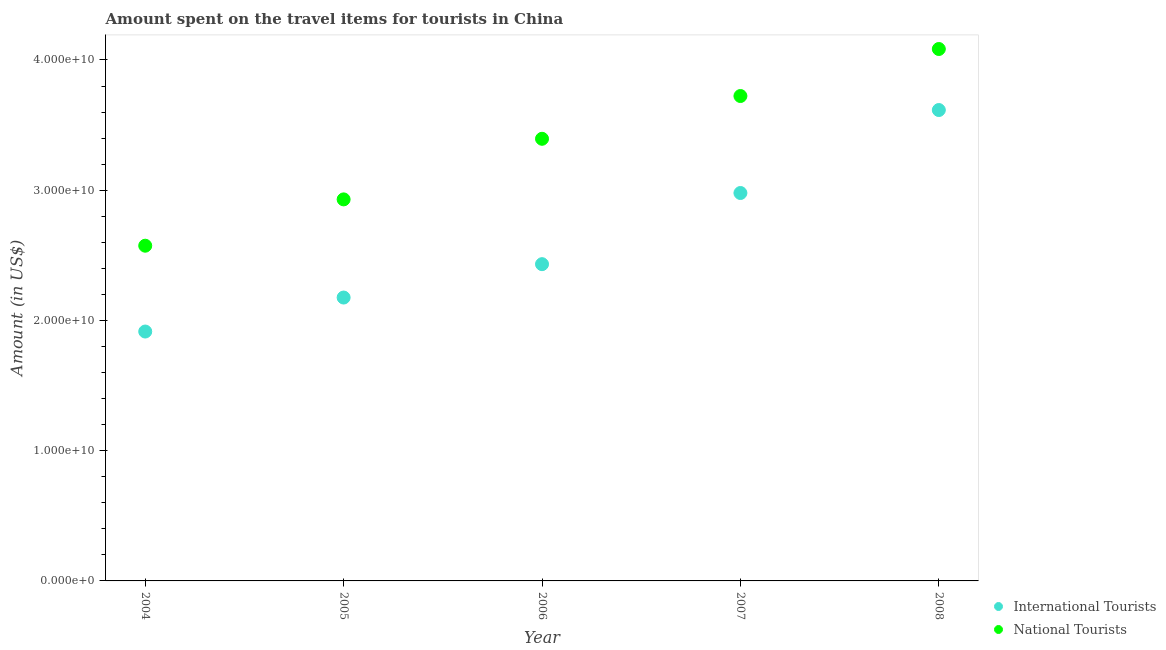Is the number of dotlines equal to the number of legend labels?
Your answer should be very brief. Yes. What is the amount spent on travel items of national tourists in 2006?
Your answer should be very brief. 3.39e+1. Across all years, what is the maximum amount spent on travel items of international tourists?
Make the answer very short. 3.62e+1. Across all years, what is the minimum amount spent on travel items of international tourists?
Offer a terse response. 1.91e+1. In which year was the amount spent on travel items of international tourists minimum?
Keep it short and to the point. 2004. What is the total amount spent on travel items of national tourists in the graph?
Your answer should be very brief. 1.67e+11. What is the difference between the amount spent on travel items of national tourists in 2006 and that in 2007?
Provide a succinct answer. -3.28e+09. What is the difference between the amount spent on travel items of international tourists in 2007 and the amount spent on travel items of national tourists in 2005?
Offer a terse response. 4.90e+08. What is the average amount spent on travel items of national tourists per year?
Provide a succinct answer. 3.34e+1. In the year 2006, what is the difference between the amount spent on travel items of international tourists and amount spent on travel items of national tourists?
Make the answer very short. -9.63e+09. In how many years, is the amount spent on travel items of national tourists greater than 22000000000 US$?
Give a very brief answer. 5. What is the ratio of the amount spent on travel items of national tourists in 2005 to that in 2008?
Ensure brevity in your answer.  0.72. What is the difference between the highest and the second highest amount spent on travel items of international tourists?
Give a very brief answer. 6.37e+09. What is the difference between the highest and the lowest amount spent on travel items of international tourists?
Provide a succinct answer. 1.70e+1. In how many years, is the amount spent on travel items of national tourists greater than the average amount spent on travel items of national tourists taken over all years?
Provide a succinct answer. 3. Does the amount spent on travel items of national tourists monotonically increase over the years?
Your answer should be very brief. Yes. How many dotlines are there?
Offer a very short reply. 2. How many years are there in the graph?
Offer a terse response. 5. What is the difference between two consecutive major ticks on the Y-axis?
Provide a succinct answer. 1.00e+1. Are the values on the major ticks of Y-axis written in scientific E-notation?
Offer a very short reply. Yes. Does the graph contain any zero values?
Offer a terse response. No. Does the graph contain grids?
Your answer should be very brief. No. How are the legend labels stacked?
Offer a terse response. Vertical. What is the title of the graph?
Offer a terse response. Amount spent on the travel items for tourists in China. Does "Highest 20% of population" appear as one of the legend labels in the graph?
Offer a terse response. No. What is the label or title of the Y-axis?
Your response must be concise. Amount (in US$). What is the Amount (in US$) of International Tourists in 2004?
Offer a very short reply. 1.91e+1. What is the Amount (in US$) in National Tourists in 2004?
Ensure brevity in your answer.  2.57e+1. What is the Amount (in US$) in International Tourists in 2005?
Keep it short and to the point. 2.18e+1. What is the Amount (in US$) in National Tourists in 2005?
Keep it short and to the point. 2.93e+1. What is the Amount (in US$) in International Tourists in 2006?
Ensure brevity in your answer.  2.43e+1. What is the Amount (in US$) in National Tourists in 2006?
Your answer should be compact. 3.39e+1. What is the Amount (in US$) in International Tourists in 2007?
Your answer should be very brief. 2.98e+1. What is the Amount (in US$) of National Tourists in 2007?
Provide a short and direct response. 3.72e+1. What is the Amount (in US$) in International Tourists in 2008?
Your answer should be compact. 3.62e+1. What is the Amount (in US$) of National Tourists in 2008?
Offer a very short reply. 4.08e+1. Across all years, what is the maximum Amount (in US$) in International Tourists?
Keep it short and to the point. 3.62e+1. Across all years, what is the maximum Amount (in US$) of National Tourists?
Offer a terse response. 4.08e+1. Across all years, what is the minimum Amount (in US$) in International Tourists?
Give a very brief answer. 1.91e+1. Across all years, what is the minimum Amount (in US$) of National Tourists?
Provide a succinct answer. 2.57e+1. What is the total Amount (in US$) in International Tourists in the graph?
Provide a short and direct response. 1.31e+11. What is the total Amount (in US$) in National Tourists in the graph?
Your response must be concise. 1.67e+11. What is the difference between the Amount (in US$) of International Tourists in 2004 and that in 2005?
Provide a succinct answer. -2.61e+09. What is the difference between the Amount (in US$) of National Tourists in 2004 and that in 2005?
Provide a short and direct response. -3.56e+09. What is the difference between the Amount (in US$) of International Tourists in 2004 and that in 2006?
Your answer should be very brief. -5.17e+09. What is the difference between the Amount (in US$) in National Tourists in 2004 and that in 2006?
Your answer should be very brief. -8.21e+09. What is the difference between the Amount (in US$) in International Tourists in 2004 and that in 2007?
Offer a terse response. -1.06e+1. What is the difference between the Amount (in US$) of National Tourists in 2004 and that in 2007?
Give a very brief answer. -1.15e+1. What is the difference between the Amount (in US$) in International Tourists in 2004 and that in 2008?
Provide a succinct answer. -1.70e+1. What is the difference between the Amount (in US$) in National Tourists in 2004 and that in 2008?
Offer a very short reply. -1.51e+1. What is the difference between the Amount (in US$) in International Tourists in 2005 and that in 2006?
Offer a terse response. -2.56e+09. What is the difference between the Amount (in US$) of National Tourists in 2005 and that in 2006?
Offer a very short reply. -4.65e+09. What is the difference between the Amount (in US$) in International Tourists in 2005 and that in 2007?
Keep it short and to the point. -8.03e+09. What is the difference between the Amount (in US$) of National Tourists in 2005 and that in 2007?
Offer a terse response. -7.94e+09. What is the difference between the Amount (in US$) in International Tourists in 2005 and that in 2008?
Keep it short and to the point. -1.44e+1. What is the difference between the Amount (in US$) in National Tourists in 2005 and that in 2008?
Your response must be concise. -1.15e+1. What is the difference between the Amount (in US$) in International Tourists in 2006 and that in 2007?
Keep it short and to the point. -5.46e+09. What is the difference between the Amount (in US$) of National Tourists in 2006 and that in 2007?
Offer a very short reply. -3.28e+09. What is the difference between the Amount (in US$) of International Tourists in 2006 and that in 2008?
Make the answer very short. -1.18e+1. What is the difference between the Amount (in US$) in National Tourists in 2006 and that in 2008?
Provide a short and direct response. -6.89e+09. What is the difference between the Amount (in US$) of International Tourists in 2007 and that in 2008?
Offer a very short reply. -6.37e+09. What is the difference between the Amount (in US$) of National Tourists in 2007 and that in 2008?
Keep it short and to the point. -3.61e+09. What is the difference between the Amount (in US$) in International Tourists in 2004 and the Amount (in US$) in National Tourists in 2005?
Offer a terse response. -1.01e+1. What is the difference between the Amount (in US$) of International Tourists in 2004 and the Amount (in US$) of National Tourists in 2006?
Your response must be concise. -1.48e+1. What is the difference between the Amount (in US$) in International Tourists in 2004 and the Amount (in US$) in National Tourists in 2007?
Your answer should be very brief. -1.81e+1. What is the difference between the Amount (in US$) in International Tourists in 2004 and the Amount (in US$) in National Tourists in 2008?
Your response must be concise. -2.17e+1. What is the difference between the Amount (in US$) in International Tourists in 2005 and the Amount (in US$) in National Tourists in 2006?
Offer a terse response. -1.22e+1. What is the difference between the Amount (in US$) in International Tourists in 2005 and the Amount (in US$) in National Tourists in 2007?
Provide a short and direct response. -1.55e+1. What is the difference between the Amount (in US$) of International Tourists in 2005 and the Amount (in US$) of National Tourists in 2008?
Offer a very short reply. -1.91e+1. What is the difference between the Amount (in US$) in International Tourists in 2006 and the Amount (in US$) in National Tourists in 2007?
Make the answer very short. -1.29e+1. What is the difference between the Amount (in US$) in International Tourists in 2006 and the Amount (in US$) in National Tourists in 2008?
Your answer should be very brief. -1.65e+1. What is the difference between the Amount (in US$) of International Tourists in 2007 and the Amount (in US$) of National Tourists in 2008?
Offer a terse response. -1.11e+1. What is the average Amount (in US$) of International Tourists per year?
Give a very brief answer. 2.62e+1. What is the average Amount (in US$) in National Tourists per year?
Provide a short and direct response. 3.34e+1. In the year 2004, what is the difference between the Amount (in US$) of International Tourists and Amount (in US$) of National Tourists?
Provide a short and direct response. -6.59e+09. In the year 2005, what is the difference between the Amount (in US$) in International Tourists and Amount (in US$) in National Tourists?
Give a very brief answer. -7.54e+09. In the year 2006, what is the difference between the Amount (in US$) of International Tourists and Amount (in US$) of National Tourists?
Offer a very short reply. -9.63e+09. In the year 2007, what is the difference between the Amount (in US$) of International Tourists and Amount (in US$) of National Tourists?
Keep it short and to the point. -7.45e+09. In the year 2008, what is the difference between the Amount (in US$) in International Tourists and Amount (in US$) in National Tourists?
Provide a succinct answer. -4.69e+09. What is the ratio of the Amount (in US$) in National Tourists in 2004 to that in 2005?
Offer a terse response. 0.88. What is the ratio of the Amount (in US$) in International Tourists in 2004 to that in 2006?
Your answer should be very brief. 0.79. What is the ratio of the Amount (in US$) in National Tourists in 2004 to that in 2006?
Offer a terse response. 0.76. What is the ratio of the Amount (in US$) in International Tourists in 2004 to that in 2007?
Keep it short and to the point. 0.64. What is the ratio of the Amount (in US$) in National Tourists in 2004 to that in 2007?
Provide a succinct answer. 0.69. What is the ratio of the Amount (in US$) in International Tourists in 2004 to that in 2008?
Keep it short and to the point. 0.53. What is the ratio of the Amount (in US$) of National Tourists in 2004 to that in 2008?
Your response must be concise. 0.63. What is the ratio of the Amount (in US$) of International Tourists in 2005 to that in 2006?
Keep it short and to the point. 0.89. What is the ratio of the Amount (in US$) of National Tourists in 2005 to that in 2006?
Make the answer very short. 0.86. What is the ratio of the Amount (in US$) of International Tourists in 2005 to that in 2007?
Provide a short and direct response. 0.73. What is the ratio of the Amount (in US$) in National Tourists in 2005 to that in 2007?
Your response must be concise. 0.79. What is the ratio of the Amount (in US$) of International Tourists in 2005 to that in 2008?
Provide a succinct answer. 0.6. What is the ratio of the Amount (in US$) in National Tourists in 2005 to that in 2008?
Ensure brevity in your answer.  0.72. What is the ratio of the Amount (in US$) in International Tourists in 2006 to that in 2007?
Provide a succinct answer. 0.82. What is the ratio of the Amount (in US$) of National Tourists in 2006 to that in 2007?
Offer a very short reply. 0.91. What is the ratio of the Amount (in US$) in International Tourists in 2006 to that in 2008?
Offer a terse response. 0.67. What is the ratio of the Amount (in US$) in National Tourists in 2006 to that in 2008?
Your answer should be compact. 0.83. What is the ratio of the Amount (in US$) in International Tourists in 2007 to that in 2008?
Offer a terse response. 0.82. What is the ratio of the Amount (in US$) of National Tourists in 2007 to that in 2008?
Provide a succinct answer. 0.91. What is the difference between the highest and the second highest Amount (in US$) in International Tourists?
Offer a terse response. 6.37e+09. What is the difference between the highest and the second highest Amount (in US$) in National Tourists?
Keep it short and to the point. 3.61e+09. What is the difference between the highest and the lowest Amount (in US$) in International Tourists?
Provide a succinct answer. 1.70e+1. What is the difference between the highest and the lowest Amount (in US$) in National Tourists?
Ensure brevity in your answer.  1.51e+1. 